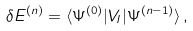<formula> <loc_0><loc_0><loc_500><loc_500>\delta E ^ { ( n ) } = \langle \Psi ^ { ( 0 ) } | V _ { I } | \Psi ^ { ( n - 1 ) } \rangle \, ,</formula> 